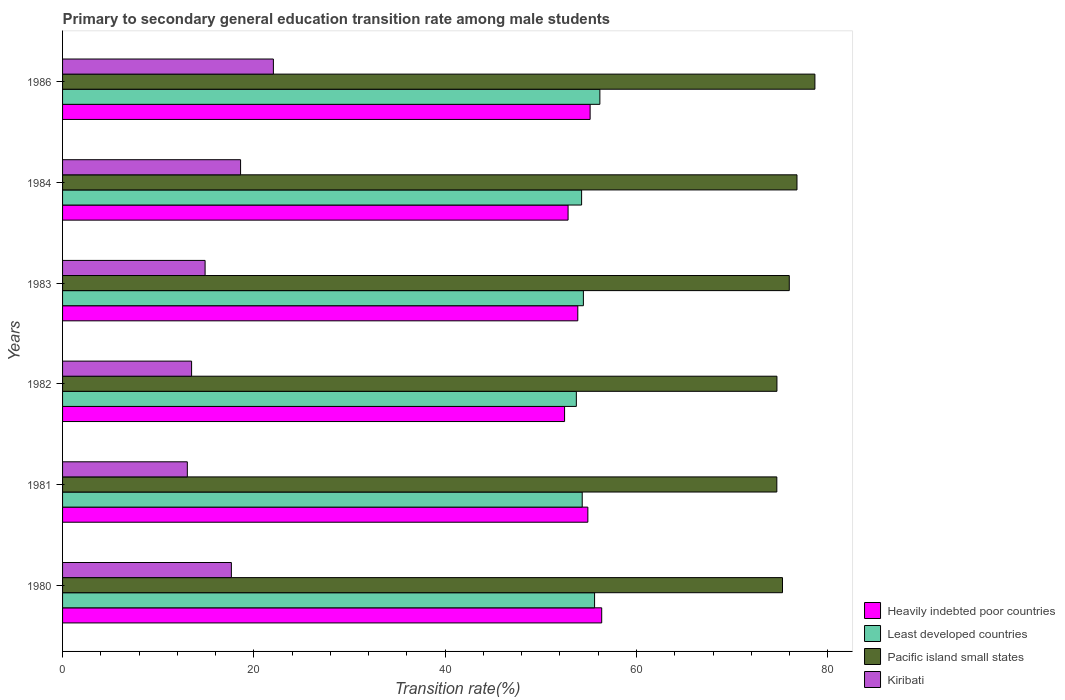How many bars are there on the 2nd tick from the top?
Ensure brevity in your answer.  4. What is the label of the 3rd group of bars from the top?
Your answer should be compact. 1983. In how many cases, is the number of bars for a given year not equal to the number of legend labels?
Give a very brief answer. 0. What is the transition rate in Least developed countries in 1982?
Offer a terse response. 53.71. Across all years, what is the maximum transition rate in Heavily indebted poor countries?
Your answer should be very brief. 56.36. Across all years, what is the minimum transition rate in Kiribati?
Make the answer very short. 13.04. In which year was the transition rate in Kiribati minimum?
Make the answer very short. 1981. What is the total transition rate in Heavily indebted poor countries in the graph?
Make the answer very short. 325.62. What is the difference between the transition rate in Kiribati in 1983 and that in 1986?
Make the answer very short. -7.14. What is the difference between the transition rate in Pacific island small states in 1981 and the transition rate in Kiribati in 1982?
Provide a succinct answer. 61.18. What is the average transition rate in Pacific island small states per year?
Ensure brevity in your answer.  76. In the year 1980, what is the difference between the transition rate in Kiribati and transition rate in Least developed countries?
Ensure brevity in your answer.  -37.97. What is the ratio of the transition rate in Pacific island small states in 1983 to that in 1984?
Provide a succinct answer. 0.99. Is the difference between the transition rate in Kiribati in 1981 and 1983 greater than the difference between the transition rate in Least developed countries in 1981 and 1983?
Keep it short and to the point. No. What is the difference between the highest and the second highest transition rate in Kiribati?
Your response must be concise. 3.43. What is the difference between the highest and the lowest transition rate in Heavily indebted poor countries?
Your answer should be compact. 3.88. Is it the case that in every year, the sum of the transition rate in Pacific island small states and transition rate in Heavily indebted poor countries is greater than the sum of transition rate in Kiribati and transition rate in Least developed countries?
Offer a very short reply. Yes. What does the 4th bar from the top in 1982 represents?
Offer a very short reply. Heavily indebted poor countries. What does the 1st bar from the bottom in 1981 represents?
Make the answer very short. Heavily indebted poor countries. Are all the bars in the graph horizontal?
Your answer should be compact. Yes. What is the difference between two consecutive major ticks on the X-axis?
Provide a short and direct response. 20. Does the graph contain any zero values?
Keep it short and to the point. No. Does the graph contain grids?
Offer a very short reply. No. Where does the legend appear in the graph?
Your answer should be very brief. Bottom right. What is the title of the graph?
Provide a succinct answer. Primary to secondary general education transition rate among male students. Does "Fiji" appear as one of the legend labels in the graph?
Your response must be concise. No. What is the label or title of the X-axis?
Give a very brief answer. Transition rate(%). What is the Transition rate(%) in Heavily indebted poor countries in 1980?
Your answer should be very brief. 56.36. What is the Transition rate(%) of Least developed countries in 1980?
Keep it short and to the point. 55.62. What is the Transition rate(%) of Pacific island small states in 1980?
Ensure brevity in your answer.  75.26. What is the Transition rate(%) in Kiribati in 1980?
Keep it short and to the point. 17.65. What is the Transition rate(%) of Heavily indebted poor countries in 1981?
Offer a very short reply. 54.91. What is the Transition rate(%) of Least developed countries in 1981?
Provide a succinct answer. 54.32. What is the Transition rate(%) in Pacific island small states in 1981?
Your response must be concise. 74.67. What is the Transition rate(%) in Kiribati in 1981?
Make the answer very short. 13.04. What is the Transition rate(%) in Heavily indebted poor countries in 1982?
Give a very brief answer. 52.48. What is the Transition rate(%) of Least developed countries in 1982?
Offer a very short reply. 53.71. What is the Transition rate(%) in Pacific island small states in 1982?
Offer a terse response. 74.68. What is the Transition rate(%) in Kiribati in 1982?
Keep it short and to the point. 13.49. What is the Transition rate(%) of Heavily indebted poor countries in 1983?
Provide a succinct answer. 53.86. What is the Transition rate(%) in Least developed countries in 1983?
Ensure brevity in your answer.  54.45. What is the Transition rate(%) of Pacific island small states in 1983?
Make the answer very short. 75.97. What is the Transition rate(%) in Kiribati in 1983?
Provide a succinct answer. 14.9. What is the Transition rate(%) in Heavily indebted poor countries in 1984?
Provide a short and direct response. 52.85. What is the Transition rate(%) in Least developed countries in 1984?
Provide a short and direct response. 54.26. What is the Transition rate(%) in Pacific island small states in 1984?
Give a very brief answer. 76.78. What is the Transition rate(%) of Kiribati in 1984?
Give a very brief answer. 18.61. What is the Transition rate(%) of Heavily indebted poor countries in 1986?
Offer a terse response. 55.15. What is the Transition rate(%) of Least developed countries in 1986?
Provide a short and direct response. 56.17. What is the Transition rate(%) of Pacific island small states in 1986?
Offer a terse response. 78.65. What is the Transition rate(%) in Kiribati in 1986?
Provide a succinct answer. 22.04. Across all years, what is the maximum Transition rate(%) in Heavily indebted poor countries?
Provide a short and direct response. 56.36. Across all years, what is the maximum Transition rate(%) of Least developed countries?
Provide a succinct answer. 56.17. Across all years, what is the maximum Transition rate(%) in Pacific island small states?
Give a very brief answer. 78.65. Across all years, what is the maximum Transition rate(%) in Kiribati?
Your answer should be compact. 22.04. Across all years, what is the minimum Transition rate(%) in Heavily indebted poor countries?
Your answer should be compact. 52.48. Across all years, what is the minimum Transition rate(%) in Least developed countries?
Offer a terse response. 53.71. Across all years, what is the minimum Transition rate(%) of Pacific island small states?
Make the answer very short. 74.67. Across all years, what is the minimum Transition rate(%) in Kiribati?
Your answer should be compact. 13.04. What is the total Transition rate(%) in Heavily indebted poor countries in the graph?
Offer a very short reply. 325.62. What is the total Transition rate(%) of Least developed countries in the graph?
Offer a very short reply. 328.53. What is the total Transition rate(%) of Pacific island small states in the graph?
Provide a succinct answer. 456.01. What is the total Transition rate(%) of Kiribati in the graph?
Provide a succinct answer. 99.73. What is the difference between the Transition rate(%) in Heavily indebted poor countries in 1980 and that in 1981?
Offer a terse response. 1.45. What is the difference between the Transition rate(%) of Least developed countries in 1980 and that in 1981?
Offer a terse response. 1.29. What is the difference between the Transition rate(%) in Pacific island small states in 1980 and that in 1981?
Provide a short and direct response. 0.59. What is the difference between the Transition rate(%) of Kiribati in 1980 and that in 1981?
Offer a terse response. 4.6. What is the difference between the Transition rate(%) of Heavily indebted poor countries in 1980 and that in 1982?
Ensure brevity in your answer.  3.88. What is the difference between the Transition rate(%) of Least developed countries in 1980 and that in 1982?
Make the answer very short. 1.91. What is the difference between the Transition rate(%) in Pacific island small states in 1980 and that in 1982?
Offer a very short reply. 0.58. What is the difference between the Transition rate(%) in Kiribati in 1980 and that in 1982?
Your answer should be compact. 4.16. What is the difference between the Transition rate(%) in Heavily indebted poor countries in 1980 and that in 1983?
Your answer should be compact. 2.5. What is the difference between the Transition rate(%) of Least developed countries in 1980 and that in 1983?
Your answer should be compact. 1.17. What is the difference between the Transition rate(%) in Pacific island small states in 1980 and that in 1983?
Make the answer very short. -0.71. What is the difference between the Transition rate(%) in Kiribati in 1980 and that in 1983?
Your response must be concise. 2.75. What is the difference between the Transition rate(%) in Heavily indebted poor countries in 1980 and that in 1984?
Your answer should be compact. 3.51. What is the difference between the Transition rate(%) of Least developed countries in 1980 and that in 1984?
Offer a very short reply. 1.36. What is the difference between the Transition rate(%) in Pacific island small states in 1980 and that in 1984?
Your response must be concise. -1.51. What is the difference between the Transition rate(%) in Kiribati in 1980 and that in 1984?
Make the answer very short. -0.96. What is the difference between the Transition rate(%) of Heavily indebted poor countries in 1980 and that in 1986?
Your response must be concise. 1.21. What is the difference between the Transition rate(%) of Least developed countries in 1980 and that in 1986?
Your answer should be compact. -0.55. What is the difference between the Transition rate(%) in Pacific island small states in 1980 and that in 1986?
Provide a succinct answer. -3.39. What is the difference between the Transition rate(%) in Kiribati in 1980 and that in 1986?
Ensure brevity in your answer.  -4.39. What is the difference between the Transition rate(%) in Heavily indebted poor countries in 1981 and that in 1982?
Your answer should be compact. 2.43. What is the difference between the Transition rate(%) in Least developed countries in 1981 and that in 1982?
Provide a short and direct response. 0.61. What is the difference between the Transition rate(%) in Pacific island small states in 1981 and that in 1982?
Provide a short and direct response. -0.01. What is the difference between the Transition rate(%) of Kiribati in 1981 and that in 1982?
Give a very brief answer. -0.45. What is the difference between the Transition rate(%) in Heavily indebted poor countries in 1981 and that in 1983?
Keep it short and to the point. 1.05. What is the difference between the Transition rate(%) of Least developed countries in 1981 and that in 1983?
Make the answer very short. -0.12. What is the difference between the Transition rate(%) of Pacific island small states in 1981 and that in 1983?
Your response must be concise. -1.3. What is the difference between the Transition rate(%) in Kiribati in 1981 and that in 1983?
Your answer should be compact. -1.86. What is the difference between the Transition rate(%) of Heavily indebted poor countries in 1981 and that in 1984?
Ensure brevity in your answer.  2.07. What is the difference between the Transition rate(%) of Least developed countries in 1981 and that in 1984?
Offer a very short reply. 0.06. What is the difference between the Transition rate(%) in Pacific island small states in 1981 and that in 1984?
Make the answer very short. -2.11. What is the difference between the Transition rate(%) of Kiribati in 1981 and that in 1984?
Make the answer very short. -5.57. What is the difference between the Transition rate(%) of Heavily indebted poor countries in 1981 and that in 1986?
Offer a terse response. -0.24. What is the difference between the Transition rate(%) in Least developed countries in 1981 and that in 1986?
Offer a terse response. -1.85. What is the difference between the Transition rate(%) of Pacific island small states in 1981 and that in 1986?
Ensure brevity in your answer.  -3.98. What is the difference between the Transition rate(%) in Kiribati in 1981 and that in 1986?
Provide a short and direct response. -9. What is the difference between the Transition rate(%) of Heavily indebted poor countries in 1982 and that in 1983?
Ensure brevity in your answer.  -1.38. What is the difference between the Transition rate(%) of Least developed countries in 1982 and that in 1983?
Your answer should be very brief. -0.74. What is the difference between the Transition rate(%) of Pacific island small states in 1982 and that in 1983?
Your answer should be very brief. -1.29. What is the difference between the Transition rate(%) in Kiribati in 1982 and that in 1983?
Give a very brief answer. -1.41. What is the difference between the Transition rate(%) of Heavily indebted poor countries in 1982 and that in 1984?
Ensure brevity in your answer.  -0.37. What is the difference between the Transition rate(%) in Least developed countries in 1982 and that in 1984?
Keep it short and to the point. -0.55. What is the difference between the Transition rate(%) in Pacific island small states in 1982 and that in 1984?
Make the answer very short. -2.1. What is the difference between the Transition rate(%) in Kiribati in 1982 and that in 1984?
Provide a succinct answer. -5.12. What is the difference between the Transition rate(%) of Heavily indebted poor countries in 1982 and that in 1986?
Your response must be concise. -2.67. What is the difference between the Transition rate(%) of Least developed countries in 1982 and that in 1986?
Your answer should be very brief. -2.46. What is the difference between the Transition rate(%) in Pacific island small states in 1982 and that in 1986?
Ensure brevity in your answer.  -3.97. What is the difference between the Transition rate(%) in Kiribati in 1982 and that in 1986?
Offer a terse response. -8.55. What is the difference between the Transition rate(%) of Least developed countries in 1983 and that in 1984?
Keep it short and to the point. 0.19. What is the difference between the Transition rate(%) in Pacific island small states in 1983 and that in 1984?
Provide a short and direct response. -0.81. What is the difference between the Transition rate(%) of Kiribati in 1983 and that in 1984?
Provide a short and direct response. -3.71. What is the difference between the Transition rate(%) of Heavily indebted poor countries in 1983 and that in 1986?
Offer a terse response. -1.29. What is the difference between the Transition rate(%) in Least developed countries in 1983 and that in 1986?
Your response must be concise. -1.72. What is the difference between the Transition rate(%) of Pacific island small states in 1983 and that in 1986?
Provide a short and direct response. -2.68. What is the difference between the Transition rate(%) of Kiribati in 1983 and that in 1986?
Offer a very short reply. -7.14. What is the difference between the Transition rate(%) of Heavily indebted poor countries in 1984 and that in 1986?
Ensure brevity in your answer.  -2.3. What is the difference between the Transition rate(%) in Least developed countries in 1984 and that in 1986?
Make the answer very short. -1.91. What is the difference between the Transition rate(%) in Pacific island small states in 1984 and that in 1986?
Your answer should be very brief. -1.87. What is the difference between the Transition rate(%) of Kiribati in 1984 and that in 1986?
Provide a short and direct response. -3.43. What is the difference between the Transition rate(%) in Heavily indebted poor countries in 1980 and the Transition rate(%) in Least developed countries in 1981?
Ensure brevity in your answer.  2.04. What is the difference between the Transition rate(%) in Heavily indebted poor countries in 1980 and the Transition rate(%) in Pacific island small states in 1981?
Your answer should be compact. -18.31. What is the difference between the Transition rate(%) in Heavily indebted poor countries in 1980 and the Transition rate(%) in Kiribati in 1981?
Make the answer very short. 43.32. What is the difference between the Transition rate(%) in Least developed countries in 1980 and the Transition rate(%) in Pacific island small states in 1981?
Make the answer very short. -19.05. What is the difference between the Transition rate(%) of Least developed countries in 1980 and the Transition rate(%) of Kiribati in 1981?
Offer a terse response. 42.57. What is the difference between the Transition rate(%) of Pacific island small states in 1980 and the Transition rate(%) of Kiribati in 1981?
Provide a succinct answer. 62.22. What is the difference between the Transition rate(%) in Heavily indebted poor countries in 1980 and the Transition rate(%) in Least developed countries in 1982?
Your response must be concise. 2.65. What is the difference between the Transition rate(%) of Heavily indebted poor countries in 1980 and the Transition rate(%) of Pacific island small states in 1982?
Offer a very short reply. -18.32. What is the difference between the Transition rate(%) of Heavily indebted poor countries in 1980 and the Transition rate(%) of Kiribati in 1982?
Make the answer very short. 42.87. What is the difference between the Transition rate(%) of Least developed countries in 1980 and the Transition rate(%) of Pacific island small states in 1982?
Offer a very short reply. -19.06. What is the difference between the Transition rate(%) in Least developed countries in 1980 and the Transition rate(%) in Kiribati in 1982?
Offer a very short reply. 42.13. What is the difference between the Transition rate(%) in Pacific island small states in 1980 and the Transition rate(%) in Kiribati in 1982?
Ensure brevity in your answer.  61.77. What is the difference between the Transition rate(%) in Heavily indebted poor countries in 1980 and the Transition rate(%) in Least developed countries in 1983?
Your response must be concise. 1.91. What is the difference between the Transition rate(%) in Heavily indebted poor countries in 1980 and the Transition rate(%) in Pacific island small states in 1983?
Provide a short and direct response. -19.61. What is the difference between the Transition rate(%) of Heavily indebted poor countries in 1980 and the Transition rate(%) of Kiribati in 1983?
Your answer should be very brief. 41.46. What is the difference between the Transition rate(%) in Least developed countries in 1980 and the Transition rate(%) in Pacific island small states in 1983?
Offer a terse response. -20.35. What is the difference between the Transition rate(%) of Least developed countries in 1980 and the Transition rate(%) of Kiribati in 1983?
Your response must be concise. 40.72. What is the difference between the Transition rate(%) in Pacific island small states in 1980 and the Transition rate(%) in Kiribati in 1983?
Offer a very short reply. 60.36. What is the difference between the Transition rate(%) in Heavily indebted poor countries in 1980 and the Transition rate(%) in Least developed countries in 1984?
Provide a short and direct response. 2.1. What is the difference between the Transition rate(%) of Heavily indebted poor countries in 1980 and the Transition rate(%) of Pacific island small states in 1984?
Give a very brief answer. -20.41. What is the difference between the Transition rate(%) of Heavily indebted poor countries in 1980 and the Transition rate(%) of Kiribati in 1984?
Keep it short and to the point. 37.75. What is the difference between the Transition rate(%) of Least developed countries in 1980 and the Transition rate(%) of Pacific island small states in 1984?
Your response must be concise. -21.16. What is the difference between the Transition rate(%) of Least developed countries in 1980 and the Transition rate(%) of Kiribati in 1984?
Provide a succinct answer. 37.01. What is the difference between the Transition rate(%) of Pacific island small states in 1980 and the Transition rate(%) of Kiribati in 1984?
Provide a succinct answer. 56.65. What is the difference between the Transition rate(%) of Heavily indebted poor countries in 1980 and the Transition rate(%) of Least developed countries in 1986?
Make the answer very short. 0.19. What is the difference between the Transition rate(%) in Heavily indebted poor countries in 1980 and the Transition rate(%) in Pacific island small states in 1986?
Your answer should be very brief. -22.29. What is the difference between the Transition rate(%) in Heavily indebted poor countries in 1980 and the Transition rate(%) in Kiribati in 1986?
Give a very brief answer. 34.32. What is the difference between the Transition rate(%) in Least developed countries in 1980 and the Transition rate(%) in Pacific island small states in 1986?
Give a very brief answer. -23.03. What is the difference between the Transition rate(%) of Least developed countries in 1980 and the Transition rate(%) of Kiribati in 1986?
Provide a short and direct response. 33.58. What is the difference between the Transition rate(%) in Pacific island small states in 1980 and the Transition rate(%) in Kiribati in 1986?
Ensure brevity in your answer.  53.22. What is the difference between the Transition rate(%) of Heavily indebted poor countries in 1981 and the Transition rate(%) of Least developed countries in 1982?
Provide a succinct answer. 1.2. What is the difference between the Transition rate(%) in Heavily indebted poor countries in 1981 and the Transition rate(%) in Pacific island small states in 1982?
Provide a short and direct response. -19.77. What is the difference between the Transition rate(%) in Heavily indebted poor countries in 1981 and the Transition rate(%) in Kiribati in 1982?
Provide a succinct answer. 41.43. What is the difference between the Transition rate(%) of Least developed countries in 1981 and the Transition rate(%) of Pacific island small states in 1982?
Your answer should be very brief. -20.36. What is the difference between the Transition rate(%) of Least developed countries in 1981 and the Transition rate(%) of Kiribati in 1982?
Your response must be concise. 40.84. What is the difference between the Transition rate(%) in Pacific island small states in 1981 and the Transition rate(%) in Kiribati in 1982?
Your answer should be very brief. 61.18. What is the difference between the Transition rate(%) of Heavily indebted poor countries in 1981 and the Transition rate(%) of Least developed countries in 1983?
Offer a very short reply. 0.47. What is the difference between the Transition rate(%) in Heavily indebted poor countries in 1981 and the Transition rate(%) in Pacific island small states in 1983?
Make the answer very short. -21.06. What is the difference between the Transition rate(%) in Heavily indebted poor countries in 1981 and the Transition rate(%) in Kiribati in 1983?
Provide a short and direct response. 40.01. What is the difference between the Transition rate(%) of Least developed countries in 1981 and the Transition rate(%) of Pacific island small states in 1983?
Offer a terse response. -21.65. What is the difference between the Transition rate(%) of Least developed countries in 1981 and the Transition rate(%) of Kiribati in 1983?
Your answer should be very brief. 39.42. What is the difference between the Transition rate(%) of Pacific island small states in 1981 and the Transition rate(%) of Kiribati in 1983?
Your answer should be compact. 59.77. What is the difference between the Transition rate(%) in Heavily indebted poor countries in 1981 and the Transition rate(%) in Least developed countries in 1984?
Your response must be concise. 0.65. What is the difference between the Transition rate(%) of Heavily indebted poor countries in 1981 and the Transition rate(%) of Pacific island small states in 1984?
Provide a short and direct response. -21.86. What is the difference between the Transition rate(%) of Heavily indebted poor countries in 1981 and the Transition rate(%) of Kiribati in 1984?
Offer a terse response. 36.3. What is the difference between the Transition rate(%) of Least developed countries in 1981 and the Transition rate(%) of Pacific island small states in 1984?
Your answer should be very brief. -22.45. What is the difference between the Transition rate(%) of Least developed countries in 1981 and the Transition rate(%) of Kiribati in 1984?
Provide a succinct answer. 35.72. What is the difference between the Transition rate(%) in Pacific island small states in 1981 and the Transition rate(%) in Kiribati in 1984?
Give a very brief answer. 56.06. What is the difference between the Transition rate(%) in Heavily indebted poor countries in 1981 and the Transition rate(%) in Least developed countries in 1986?
Ensure brevity in your answer.  -1.26. What is the difference between the Transition rate(%) in Heavily indebted poor countries in 1981 and the Transition rate(%) in Pacific island small states in 1986?
Your response must be concise. -23.74. What is the difference between the Transition rate(%) of Heavily indebted poor countries in 1981 and the Transition rate(%) of Kiribati in 1986?
Your response must be concise. 32.88. What is the difference between the Transition rate(%) in Least developed countries in 1981 and the Transition rate(%) in Pacific island small states in 1986?
Provide a short and direct response. -24.33. What is the difference between the Transition rate(%) of Least developed countries in 1981 and the Transition rate(%) of Kiribati in 1986?
Give a very brief answer. 32.29. What is the difference between the Transition rate(%) of Pacific island small states in 1981 and the Transition rate(%) of Kiribati in 1986?
Your answer should be compact. 52.63. What is the difference between the Transition rate(%) in Heavily indebted poor countries in 1982 and the Transition rate(%) in Least developed countries in 1983?
Offer a very short reply. -1.97. What is the difference between the Transition rate(%) of Heavily indebted poor countries in 1982 and the Transition rate(%) of Pacific island small states in 1983?
Make the answer very short. -23.49. What is the difference between the Transition rate(%) of Heavily indebted poor countries in 1982 and the Transition rate(%) of Kiribati in 1983?
Your response must be concise. 37.58. What is the difference between the Transition rate(%) of Least developed countries in 1982 and the Transition rate(%) of Pacific island small states in 1983?
Provide a succinct answer. -22.26. What is the difference between the Transition rate(%) in Least developed countries in 1982 and the Transition rate(%) in Kiribati in 1983?
Keep it short and to the point. 38.81. What is the difference between the Transition rate(%) of Pacific island small states in 1982 and the Transition rate(%) of Kiribati in 1983?
Provide a succinct answer. 59.78. What is the difference between the Transition rate(%) in Heavily indebted poor countries in 1982 and the Transition rate(%) in Least developed countries in 1984?
Keep it short and to the point. -1.78. What is the difference between the Transition rate(%) of Heavily indebted poor countries in 1982 and the Transition rate(%) of Pacific island small states in 1984?
Provide a succinct answer. -24.3. What is the difference between the Transition rate(%) of Heavily indebted poor countries in 1982 and the Transition rate(%) of Kiribati in 1984?
Ensure brevity in your answer.  33.87. What is the difference between the Transition rate(%) in Least developed countries in 1982 and the Transition rate(%) in Pacific island small states in 1984?
Your response must be concise. -23.07. What is the difference between the Transition rate(%) in Least developed countries in 1982 and the Transition rate(%) in Kiribati in 1984?
Offer a terse response. 35.1. What is the difference between the Transition rate(%) in Pacific island small states in 1982 and the Transition rate(%) in Kiribati in 1984?
Offer a very short reply. 56.07. What is the difference between the Transition rate(%) in Heavily indebted poor countries in 1982 and the Transition rate(%) in Least developed countries in 1986?
Your response must be concise. -3.69. What is the difference between the Transition rate(%) in Heavily indebted poor countries in 1982 and the Transition rate(%) in Pacific island small states in 1986?
Provide a short and direct response. -26.17. What is the difference between the Transition rate(%) of Heavily indebted poor countries in 1982 and the Transition rate(%) of Kiribati in 1986?
Ensure brevity in your answer.  30.44. What is the difference between the Transition rate(%) of Least developed countries in 1982 and the Transition rate(%) of Pacific island small states in 1986?
Your response must be concise. -24.94. What is the difference between the Transition rate(%) of Least developed countries in 1982 and the Transition rate(%) of Kiribati in 1986?
Your response must be concise. 31.67. What is the difference between the Transition rate(%) of Pacific island small states in 1982 and the Transition rate(%) of Kiribati in 1986?
Your answer should be compact. 52.64. What is the difference between the Transition rate(%) in Heavily indebted poor countries in 1983 and the Transition rate(%) in Least developed countries in 1984?
Offer a very short reply. -0.4. What is the difference between the Transition rate(%) in Heavily indebted poor countries in 1983 and the Transition rate(%) in Pacific island small states in 1984?
Offer a very short reply. -22.91. What is the difference between the Transition rate(%) in Heavily indebted poor countries in 1983 and the Transition rate(%) in Kiribati in 1984?
Your response must be concise. 35.25. What is the difference between the Transition rate(%) of Least developed countries in 1983 and the Transition rate(%) of Pacific island small states in 1984?
Your answer should be compact. -22.33. What is the difference between the Transition rate(%) of Least developed countries in 1983 and the Transition rate(%) of Kiribati in 1984?
Offer a very short reply. 35.84. What is the difference between the Transition rate(%) of Pacific island small states in 1983 and the Transition rate(%) of Kiribati in 1984?
Keep it short and to the point. 57.36. What is the difference between the Transition rate(%) in Heavily indebted poor countries in 1983 and the Transition rate(%) in Least developed countries in 1986?
Your answer should be very brief. -2.31. What is the difference between the Transition rate(%) of Heavily indebted poor countries in 1983 and the Transition rate(%) of Pacific island small states in 1986?
Provide a short and direct response. -24.79. What is the difference between the Transition rate(%) in Heavily indebted poor countries in 1983 and the Transition rate(%) in Kiribati in 1986?
Offer a terse response. 31.82. What is the difference between the Transition rate(%) in Least developed countries in 1983 and the Transition rate(%) in Pacific island small states in 1986?
Provide a short and direct response. -24.2. What is the difference between the Transition rate(%) of Least developed countries in 1983 and the Transition rate(%) of Kiribati in 1986?
Your answer should be very brief. 32.41. What is the difference between the Transition rate(%) of Pacific island small states in 1983 and the Transition rate(%) of Kiribati in 1986?
Provide a succinct answer. 53.93. What is the difference between the Transition rate(%) in Heavily indebted poor countries in 1984 and the Transition rate(%) in Least developed countries in 1986?
Keep it short and to the point. -3.32. What is the difference between the Transition rate(%) of Heavily indebted poor countries in 1984 and the Transition rate(%) of Pacific island small states in 1986?
Make the answer very short. -25.8. What is the difference between the Transition rate(%) of Heavily indebted poor countries in 1984 and the Transition rate(%) of Kiribati in 1986?
Your response must be concise. 30.81. What is the difference between the Transition rate(%) of Least developed countries in 1984 and the Transition rate(%) of Pacific island small states in 1986?
Give a very brief answer. -24.39. What is the difference between the Transition rate(%) in Least developed countries in 1984 and the Transition rate(%) in Kiribati in 1986?
Your answer should be compact. 32.22. What is the difference between the Transition rate(%) in Pacific island small states in 1984 and the Transition rate(%) in Kiribati in 1986?
Give a very brief answer. 54.74. What is the average Transition rate(%) of Heavily indebted poor countries per year?
Make the answer very short. 54.27. What is the average Transition rate(%) of Least developed countries per year?
Provide a succinct answer. 54.76. What is the average Transition rate(%) in Pacific island small states per year?
Your answer should be compact. 76. What is the average Transition rate(%) in Kiribati per year?
Your answer should be very brief. 16.62. In the year 1980, what is the difference between the Transition rate(%) in Heavily indebted poor countries and Transition rate(%) in Least developed countries?
Make the answer very short. 0.75. In the year 1980, what is the difference between the Transition rate(%) in Heavily indebted poor countries and Transition rate(%) in Pacific island small states?
Your answer should be very brief. -18.9. In the year 1980, what is the difference between the Transition rate(%) of Heavily indebted poor countries and Transition rate(%) of Kiribati?
Offer a terse response. 38.71. In the year 1980, what is the difference between the Transition rate(%) of Least developed countries and Transition rate(%) of Pacific island small states?
Make the answer very short. -19.65. In the year 1980, what is the difference between the Transition rate(%) in Least developed countries and Transition rate(%) in Kiribati?
Ensure brevity in your answer.  37.97. In the year 1980, what is the difference between the Transition rate(%) of Pacific island small states and Transition rate(%) of Kiribati?
Offer a very short reply. 57.61. In the year 1981, what is the difference between the Transition rate(%) of Heavily indebted poor countries and Transition rate(%) of Least developed countries?
Provide a succinct answer. 0.59. In the year 1981, what is the difference between the Transition rate(%) in Heavily indebted poor countries and Transition rate(%) in Pacific island small states?
Ensure brevity in your answer.  -19.75. In the year 1981, what is the difference between the Transition rate(%) of Heavily indebted poor countries and Transition rate(%) of Kiribati?
Your response must be concise. 41.87. In the year 1981, what is the difference between the Transition rate(%) of Least developed countries and Transition rate(%) of Pacific island small states?
Offer a terse response. -20.34. In the year 1981, what is the difference between the Transition rate(%) in Least developed countries and Transition rate(%) in Kiribati?
Give a very brief answer. 41.28. In the year 1981, what is the difference between the Transition rate(%) of Pacific island small states and Transition rate(%) of Kiribati?
Your answer should be very brief. 61.63. In the year 1982, what is the difference between the Transition rate(%) in Heavily indebted poor countries and Transition rate(%) in Least developed countries?
Your answer should be very brief. -1.23. In the year 1982, what is the difference between the Transition rate(%) in Heavily indebted poor countries and Transition rate(%) in Pacific island small states?
Offer a very short reply. -22.2. In the year 1982, what is the difference between the Transition rate(%) in Heavily indebted poor countries and Transition rate(%) in Kiribati?
Ensure brevity in your answer.  38.99. In the year 1982, what is the difference between the Transition rate(%) in Least developed countries and Transition rate(%) in Pacific island small states?
Offer a very short reply. -20.97. In the year 1982, what is the difference between the Transition rate(%) of Least developed countries and Transition rate(%) of Kiribati?
Offer a very short reply. 40.22. In the year 1982, what is the difference between the Transition rate(%) in Pacific island small states and Transition rate(%) in Kiribati?
Your answer should be very brief. 61.19. In the year 1983, what is the difference between the Transition rate(%) in Heavily indebted poor countries and Transition rate(%) in Least developed countries?
Offer a very short reply. -0.58. In the year 1983, what is the difference between the Transition rate(%) of Heavily indebted poor countries and Transition rate(%) of Pacific island small states?
Provide a succinct answer. -22.11. In the year 1983, what is the difference between the Transition rate(%) in Heavily indebted poor countries and Transition rate(%) in Kiribati?
Give a very brief answer. 38.96. In the year 1983, what is the difference between the Transition rate(%) of Least developed countries and Transition rate(%) of Pacific island small states?
Provide a short and direct response. -21.52. In the year 1983, what is the difference between the Transition rate(%) of Least developed countries and Transition rate(%) of Kiribati?
Offer a terse response. 39.55. In the year 1983, what is the difference between the Transition rate(%) of Pacific island small states and Transition rate(%) of Kiribati?
Offer a very short reply. 61.07. In the year 1984, what is the difference between the Transition rate(%) in Heavily indebted poor countries and Transition rate(%) in Least developed countries?
Provide a succinct answer. -1.41. In the year 1984, what is the difference between the Transition rate(%) of Heavily indebted poor countries and Transition rate(%) of Pacific island small states?
Give a very brief answer. -23.93. In the year 1984, what is the difference between the Transition rate(%) of Heavily indebted poor countries and Transition rate(%) of Kiribati?
Offer a very short reply. 34.24. In the year 1984, what is the difference between the Transition rate(%) in Least developed countries and Transition rate(%) in Pacific island small states?
Provide a short and direct response. -22.52. In the year 1984, what is the difference between the Transition rate(%) in Least developed countries and Transition rate(%) in Kiribati?
Give a very brief answer. 35.65. In the year 1984, what is the difference between the Transition rate(%) in Pacific island small states and Transition rate(%) in Kiribati?
Provide a short and direct response. 58.17. In the year 1986, what is the difference between the Transition rate(%) of Heavily indebted poor countries and Transition rate(%) of Least developed countries?
Ensure brevity in your answer.  -1.02. In the year 1986, what is the difference between the Transition rate(%) in Heavily indebted poor countries and Transition rate(%) in Pacific island small states?
Offer a very short reply. -23.5. In the year 1986, what is the difference between the Transition rate(%) in Heavily indebted poor countries and Transition rate(%) in Kiribati?
Your answer should be very brief. 33.11. In the year 1986, what is the difference between the Transition rate(%) in Least developed countries and Transition rate(%) in Pacific island small states?
Provide a short and direct response. -22.48. In the year 1986, what is the difference between the Transition rate(%) in Least developed countries and Transition rate(%) in Kiribati?
Offer a terse response. 34.13. In the year 1986, what is the difference between the Transition rate(%) in Pacific island small states and Transition rate(%) in Kiribati?
Your answer should be compact. 56.61. What is the ratio of the Transition rate(%) of Heavily indebted poor countries in 1980 to that in 1981?
Ensure brevity in your answer.  1.03. What is the ratio of the Transition rate(%) of Least developed countries in 1980 to that in 1981?
Your answer should be very brief. 1.02. What is the ratio of the Transition rate(%) in Pacific island small states in 1980 to that in 1981?
Keep it short and to the point. 1.01. What is the ratio of the Transition rate(%) in Kiribati in 1980 to that in 1981?
Provide a succinct answer. 1.35. What is the ratio of the Transition rate(%) of Heavily indebted poor countries in 1980 to that in 1982?
Ensure brevity in your answer.  1.07. What is the ratio of the Transition rate(%) in Least developed countries in 1980 to that in 1982?
Provide a short and direct response. 1.04. What is the ratio of the Transition rate(%) in Kiribati in 1980 to that in 1982?
Ensure brevity in your answer.  1.31. What is the ratio of the Transition rate(%) of Heavily indebted poor countries in 1980 to that in 1983?
Make the answer very short. 1.05. What is the ratio of the Transition rate(%) in Least developed countries in 1980 to that in 1983?
Give a very brief answer. 1.02. What is the ratio of the Transition rate(%) of Kiribati in 1980 to that in 1983?
Your answer should be very brief. 1.18. What is the ratio of the Transition rate(%) in Heavily indebted poor countries in 1980 to that in 1984?
Provide a succinct answer. 1.07. What is the ratio of the Transition rate(%) in Least developed countries in 1980 to that in 1984?
Offer a very short reply. 1.02. What is the ratio of the Transition rate(%) in Pacific island small states in 1980 to that in 1984?
Your response must be concise. 0.98. What is the ratio of the Transition rate(%) of Kiribati in 1980 to that in 1984?
Offer a very short reply. 0.95. What is the ratio of the Transition rate(%) of Heavily indebted poor countries in 1980 to that in 1986?
Provide a short and direct response. 1.02. What is the ratio of the Transition rate(%) of Pacific island small states in 1980 to that in 1986?
Keep it short and to the point. 0.96. What is the ratio of the Transition rate(%) of Kiribati in 1980 to that in 1986?
Your answer should be compact. 0.8. What is the ratio of the Transition rate(%) in Heavily indebted poor countries in 1981 to that in 1982?
Ensure brevity in your answer.  1.05. What is the ratio of the Transition rate(%) in Least developed countries in 1981 to that in 1982?
Provide a succinct answer. 1.01. What is the ratio of the Transition rate(%) of Pacific island small states in 1981 to that in 1982?
Your answer should be compact. 1. What is the ratio of the Transition rate(%) in Kiribati in 1981 to that in 1982?
Make the answer very short. 0.97. What is the ratio of the Transition rate(%) in Heavily indebted poor countries in 1981 to that in 1983?
Give a very brief answer. 1.02. What is the ratio of the Transition rate(%) in Least developed countries in 1981 to that in 1983?
Provide a short and direct response. 1. What is the ratio of the Transition rate(%) of Pacific island small states in 1981 to that in 1983?
Keep it short and to the point. 0.98. What is the ratio of the Transition rate(%) in Kiribati in 1981 to that in 1983?
Offer a terse response. 0.88. What is the ratio of the Transition rate(%) in Heavily indebted poor countries in 1981 to that in 1984?
Give a very brief answer. 1.04. What is the ratio of the Transition rate(%) of Least developed countries in 1981 to that in 1984?
Make the answer very short. 1. What is the ratio of the Transition rate(%) in Pacific island small states in 1981 to that in 1984?
Your answer should be very brief. 0.97. What is the ratio of the Transition rate(%) in Kiribati in 1981 to that in 1984?
Ensure brevity in your answer.  0.7. What is the ratio of the Transition rate(%) of Heavily indebted poor countries in 1981 to that in 1986?
Ensure brevity in your answer.  1. What is the ratio of the Transition rate(%) of Least developed countries in 1981 to that in 1986?
Provide a succinct answer. 0.97. What is the ratio of the Transition rate(%) of Pacific island small states in 1981 to that in 1986?
Your response must be concise. 0.95. What is the ratio of the Transition rate(%) of Kiribati in 1981 to that in 1986?
Offer a terse response. 0.59. What is the ratio of the Transition rate(%) in Heavily indebted poor countries in 1982 to that in 1983?
Your answer should be very brief. 0.97. What is the ratio of the Transition rate(%) of Least developed countries in 1982 to that in 1983?
Your answer should be compact. 0.99. What is the ratio of the Transition rate(%) in Kiribati in 1982 to that in 1983?
Provide a short and direct response. 0.91. What is the ratio of the Transition rate(%) of Least developed countries in 1982 to that in 1984?
Your answer should be very brief. 0.99. What is the ratio of the Transition rate(%) of Pacific island small states in 1982 to that in 1984?
Make the answer very short. 0.97. What is the ratio of the Transition rate(%) in Kiribati in 1982 to that in 1984?
Keep it short and to the point. 0.72. What is the ratio of the Transition rate(%) in Heavily indebted poor countries in 1982 to that in 1986?
Make the answer very short. 0.95. What is the ratio of the Transition rate(%) of Least developed countries in 1982 to that in 1986?
Your answer should be very brief. 0.96. What is the ratio of the Transition rate(%) in Pacific island small states in 1982 to that in 1986?
Offer a very short reply. 0.95. What is the ratio of the Transition rate(%) of Kiribati in 1982 to that in 1986?
Your answer should be very brief. 0.61. What is the ratio of the Transition rate(%) of Heavily indebted poor countries in 1983 to that in 1984?
Your answer should be compact. 1.02. What is the ratio of the Transition rate(%) in Least developed countries in 1983 to that in 1984?
Offer a very short reply. 1. What is the ratio of the Transition rate(%) of Kiribati in 1983 to that in 1984?
Your answer should be compact. 0.8. What is the ratio of the Transition rate(%) in Heavily indebted poor countries in 1983 to that in 1986?
Make the answer very short. 0.98. What is the ratio of the Transition rate(%) in Least developed countries in 1983 to that in 1986?
Your response must be concise. 0.97. What is the ratio of the Transition rate(%) in Pacific island small states in 1983 to that in 1986?
Keep it short and to the point. 0.97. What is the ratio of the Transition rate(%) in Kiribati in 1983 to that in 1986?
Keep it short and to the point. 0.68. What is the ratio of the Transition rate(%) in Heavily indebted poor countries in 1984 to that in 1986?
Your response must be concise. 0.96. What is the ratio of the Transition rate(%) in Pacific island small states in 1984 to that in 1986?
Offer a terse response. 0.98. What is the ratio of the Transition rate(%) in Kiribati in 1984 to that in 1986?
Make the answer very short. 0.84. What is the difference between the highest and the second highest Transition rate(%) in Heavily indebted poor countries?
Ensure brevity in your answer.  1.21. What is the difference between the highest and the second highest Transition rate(%) in Least developed countries?
Provide a short and direct response. 0.55. What is the difference between the highest and the second highest Transition rate(%) in Pacific island small states?
Offer a very short reply. 1.87. What is the difference between the highest and the second highest Transition rate(%) in Kiribati?
Offer a terse response. 3.43. What is the difference between the highest and the lowest Transition rate(%) in Heavily indebted poor countries?
Keep it short and to the point. 3.88. What is the difference between the highest and the lowest Transition rate(%) of Least developed countries?
Ensure brevity in your answer.  2.46. What is the difference between the highest and the lowest Transition rate(%) in Pacific island small states?
Your answer should be very brief. 3.98. What is the difference between the highest and the lowest Transition rate(%) of Kiribati?
Provide a succinct answer. 9. 